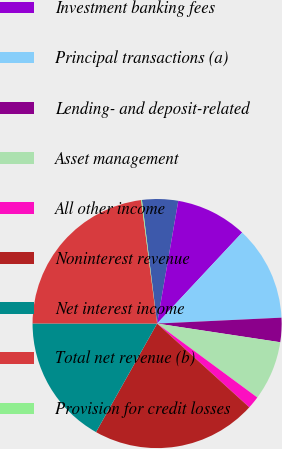<chart> <loc_0><loc_0><loc_500><loc_500><pie_chart><fcel>(in millions)<fcel>Investment banking fees<fcel>Principal transactions (a)<fcel>Lending- and deposit-related<fcel>Asset management<fcel>All other income<fcel>Noninterest revenue<fcel>Net interest income<fcel>Total net revenue (b)<fcel>Provision for credit losses<nl><fcel>4.67%<fcel>9.24%<fcel>12.28%<fcel>3.15%<fcel>7.72%<fcel>1.62%<fcel>21.42%<fcel>16.85%<fcel>22.94%<fcel>0.1%<nl></chart> 